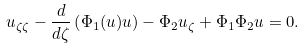<formula> <loc_0><loc_0><loc_500><loc_500>u _ { \zeta \zeta } - \frac { d } { d \zeta } \left ( \Phi _ { 1 } ( u ) u \right ) - \Phi _ { 2 } u _ { \zeta } + \Phi _ { 1 } \Phi _ { 2 } u = 0 .</formula> 